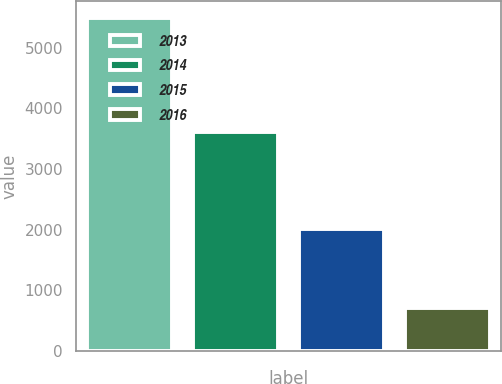Convert chart. <chart><loc_0><loc_0><loc_500><loc_500><bar_chart><fcel>2013<fcel>2014<fcel>2015<fcel>2016<nl><fcel>5490<fcel>3615<fcel>2005<fcel>711<nl></chart> 